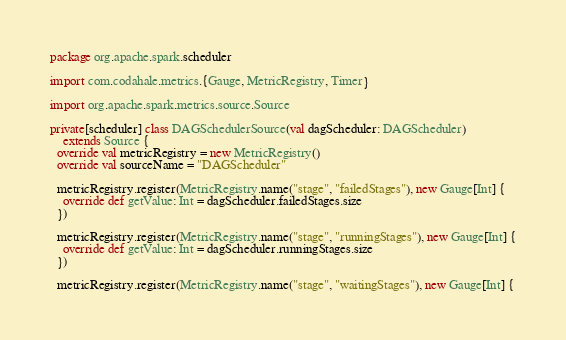Convert code to text. <code><loc_0><loc_0><loc_500><loc_500><_Scala_>package org.apache.spark.scheduler

import com.codahale.metrics.{Gauge, MetricRegistry, Timer}

import org.apache.spark.metrics.source.Source

private[scheduler] class DAGSchedulerSource(val dagScheduler: DAGScheduler)
    extends Source {
  override val metricRegistry = new MetricRegistry()
  override val sourceName = "DAGScheduler"

  metricRegistry.register(MetricRegistry.name("stage", "failedStages"), new Gauge[Int] {
    override def getValue: Int = dagScheduler.failedStages.size
  })

  metricRegistry.register(MetricRegistry.name("stage", "runningStages"), new Gauge[Int] {
    override def getValue: Int = dagScheduler.runningStages.size
  })

  metricRegistry.register(MetricRegistry.name("stage", "waitingStages"), new Gauge[Int] {</code> 